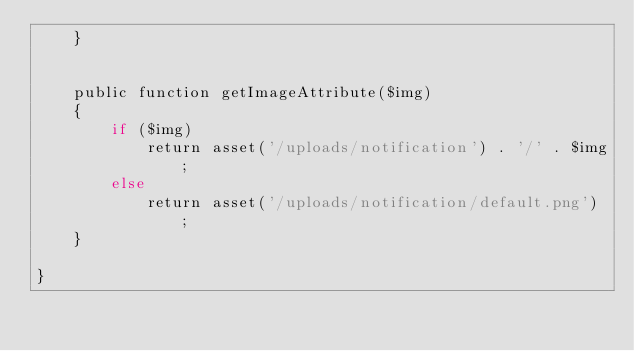<code> <loc_0><loc_0><loc_500><loc_500><_PHP_>    }


    public function getImageAttribute($img)
    {
        if ($img)
            return asset('/uploads/notification') . '/' . $img;
        else
            return asset('/uploads/notification/default.png') ;
    }

}
</code> 